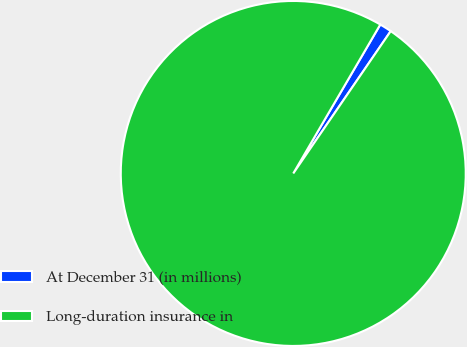Convert chart to OTSL. <chart><loc_0><loc_0><loc_500><loc_500><pie_chart><fcel>At December 31 (in millions)<fcel>Long-duration insurance in<nl><fcel>1.14%<fcel>98.86%<nl></chart> 